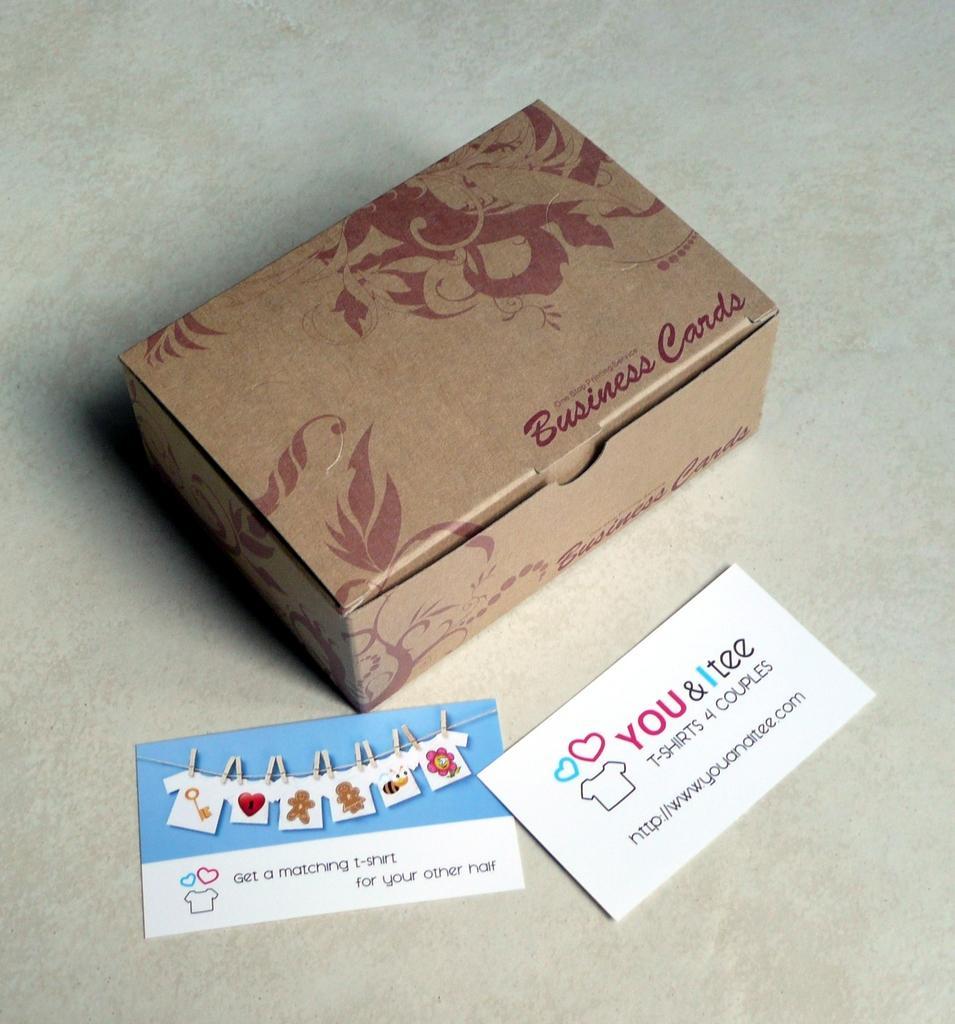In one or two sentences, can you explain what this image depicts? In this picture we can see a box and cards on the platform. 